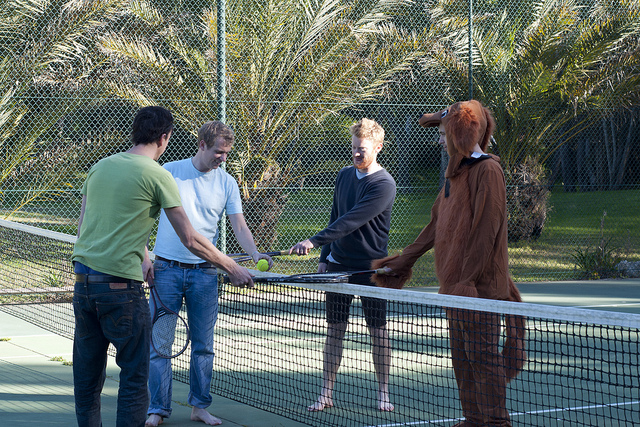Please provide a short description for this region: [0.11, 0.33, 0.39, 0.82]. A man in a green shirt on the left side. 